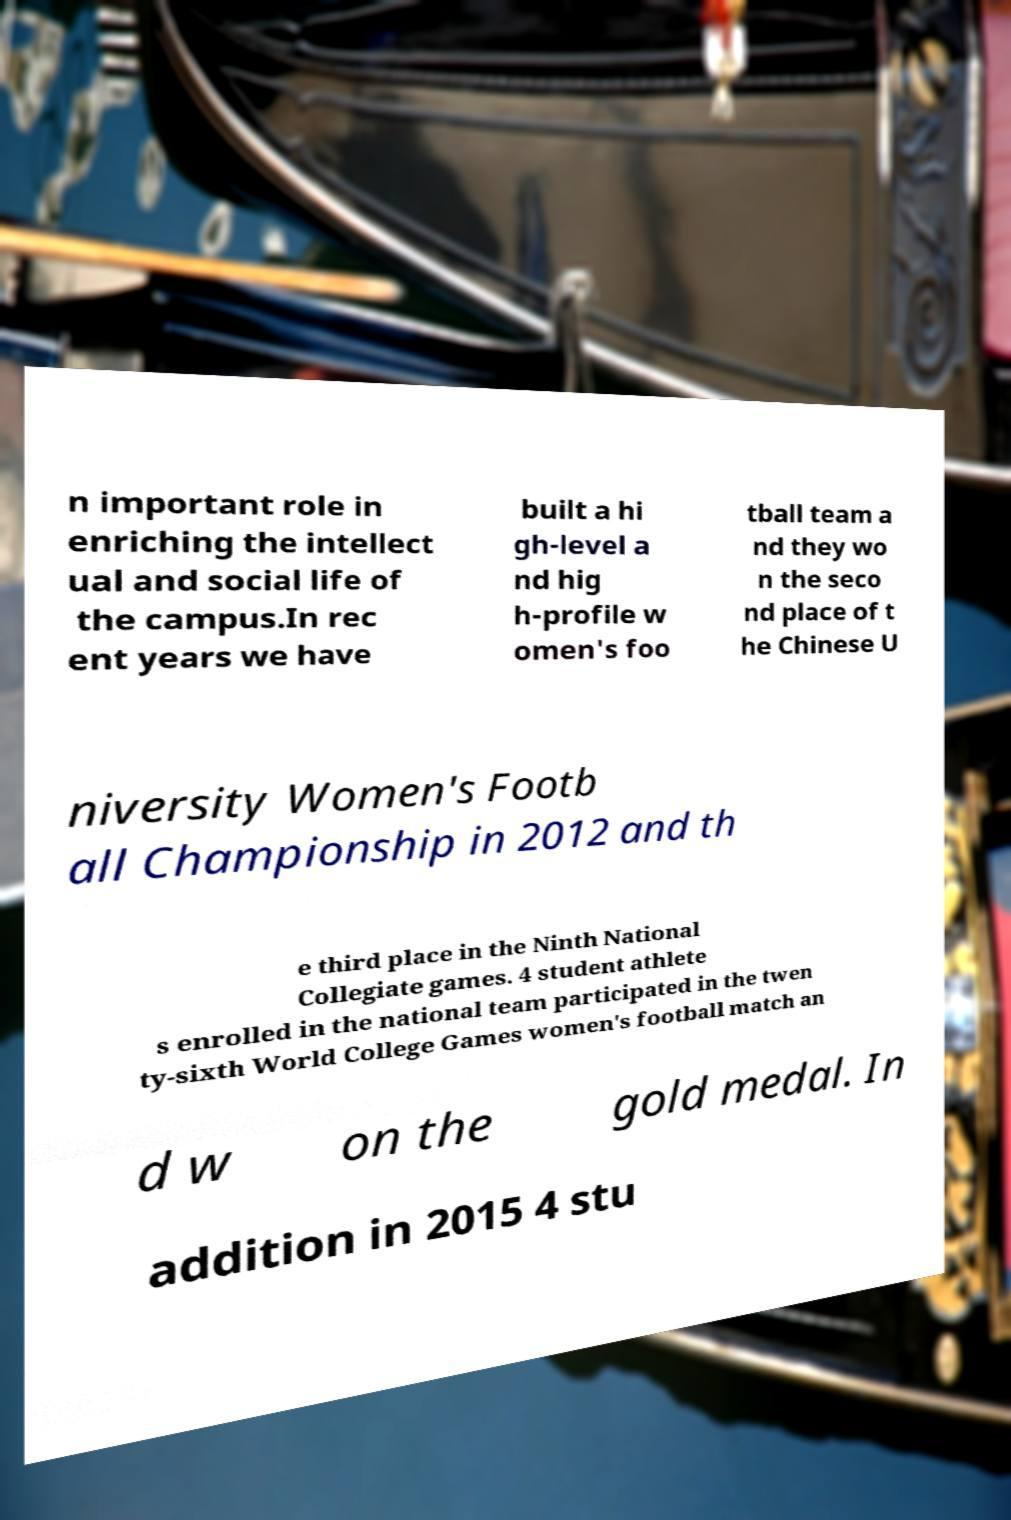Can you accurately transcribe the text from the provided image for me? n important role in enriching the intellect ual and social life of the campus.In rec ent years we have built a hi gh-level a nd hig h-profile w omen's foo tball team a nd they wo n the seco nd place of t he Chinese U niversity Women's Footb all Championship in 2012 and th e third place in the Ninth National Collegiate games. 4 student athlete s enrolled in the national team participated in the twen ty-sixth World College Games women's football match an d w on the gold medal. In addition in 2015 4 stu 